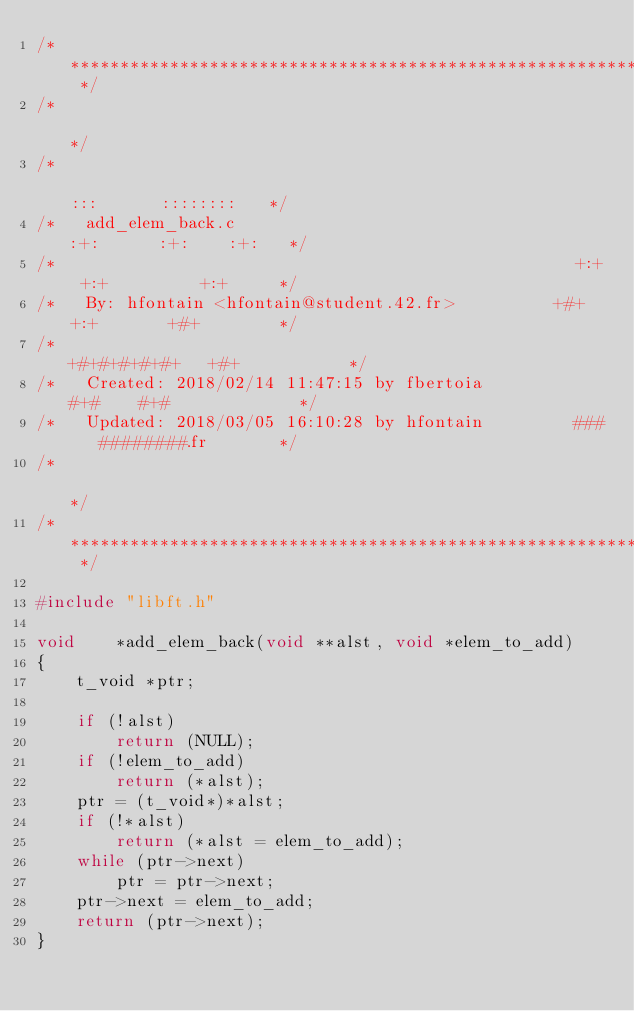<code> <loc_0><loc_0><loc_500><loc_500><_C_>/* ************************************************************************** */
/*                                                                            */
/*                                                        :::      ::::::::   */
/*   add_elem_back.c                                    :+:      :+:    :+:   */
/*                                                    +:+ +:+         +:+     */
/*   By: hfontain <hfontain@student.42.fr>          +#+  +:+       +#+        */
/*                                                +#+#+#+#+#+   +#+           */
/*   Created: 2018/02/14 11:47:15 by fbertoia          #+#    #+#             */
/*   Updated: 2018/03/05 16:10:28 by hfontain         ###   ########.fr       */
/*                                                                            */
/* ************************************************************************** */

#include "libft.h"

void	*add_elem_back(void **alst, void *elem_to_add)
{
	t_void *ptr;

	if (!alst)
		return (NULL);
	if (!elem_to_add)
		return (*alst);
	ptr = (t_void*)*alst;
	if (!*alst)
		return (*alst = elem_to_add);
	while (ptr->next)
		ptr = ptr->next;
	ptr->next = elem_to_add;
	return (ptr->next);
}
</code> 